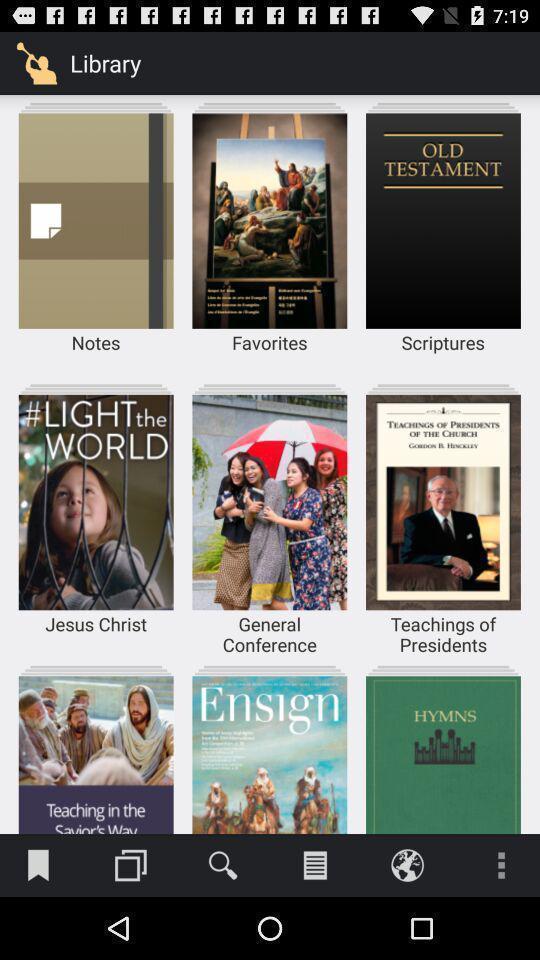Summarize the information in this screenshot. Screen display list of various categories in spiritual app. 